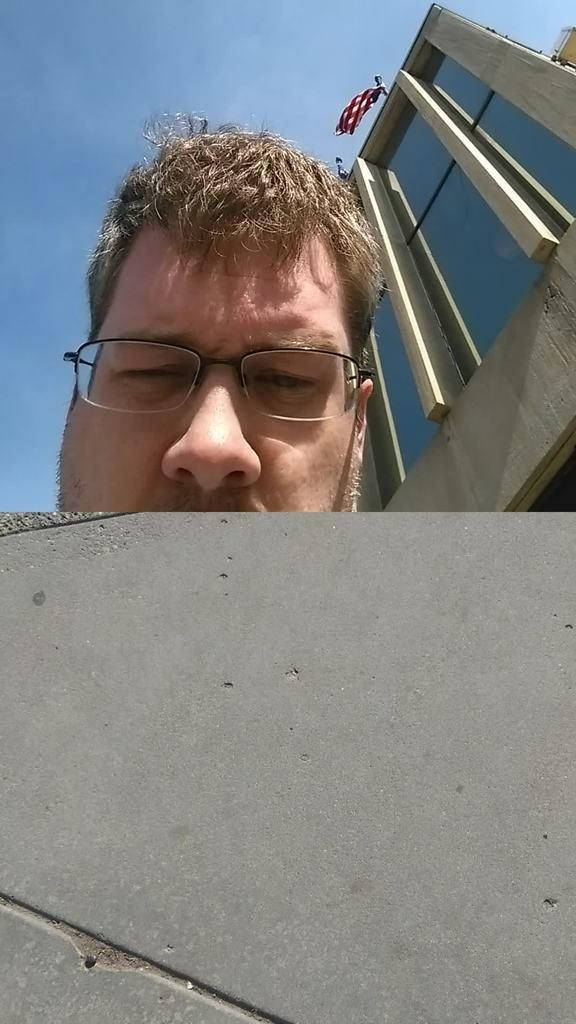What type of object is in the image? There is a cement object in the image. What is the man doing with the cement object? The man is hiding his face behind the cement object. How much of the person's face is visible? The person's face is partially visible. What can be seen in the background of the image? There is a building behind the person. What type of rose is the man holding in the image? There is no rose present in the image; the man is hiding his face behind a cement object. Is the person playing a guitar in the image? There is no guitar present in the image; the man is hiding his face behind a cement object. 